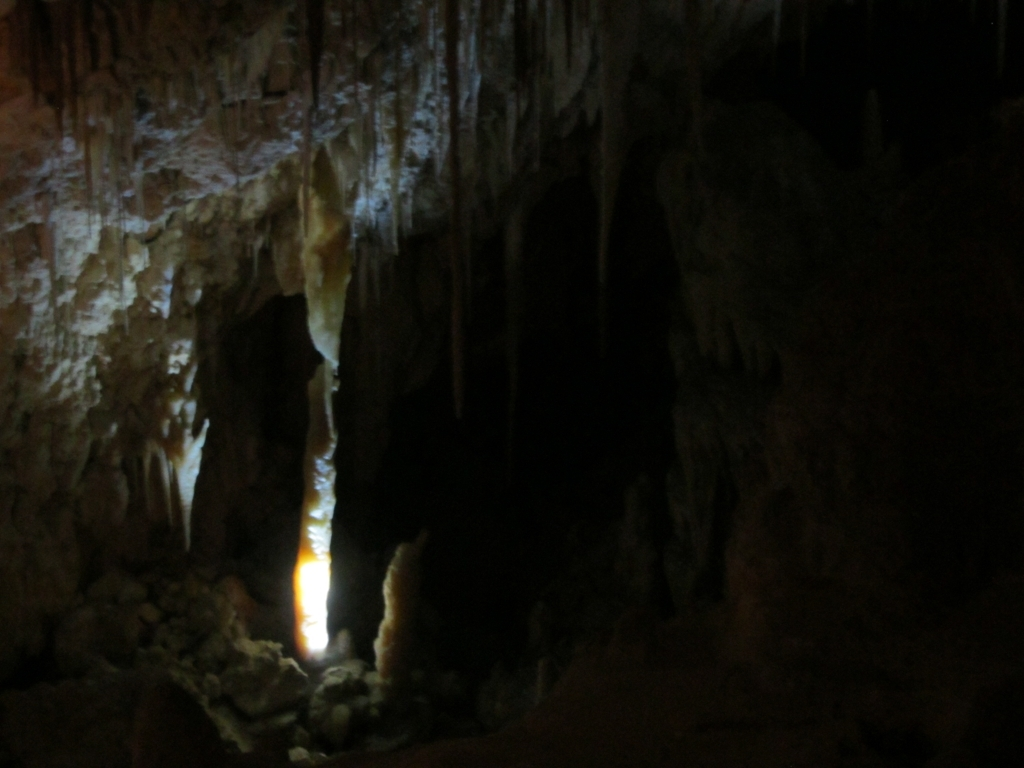What sort of adjustments would a photographer need to make to capture a well-exposed photo in this environment? A photographer would need to adjust the camera settings to accommodate the low light environment. This includes using a slow shutter speed to allow more light to reach the sensor, a wide aperture to increase the amount of light entering the lens, and possibly a higher ISO setting to make the camera sensor more sensitive to light. A tripod would likely be necessary to steady the camera for the slow shutter speed to avoid blurring, and manual focusing might be required if the automatic focus struggles in the dim conditions. Are there any particular challenges or risks associated with taking pictures in such settings? Indeed, there are challenges and risks when taking pictures in a cave. The high humidity and potential for water droplets can damage camera equipment. The uneven and slippery ground presents a physical hazard. Additionally, low light requires longer exposure times, increasing the risk of motion blur. Flashes and artificial lighting can disrupt the natural scene and may affect any wildlife present. Therefore, photographers must take care to preserve the cave's delicate environment while capturing its beauty. 